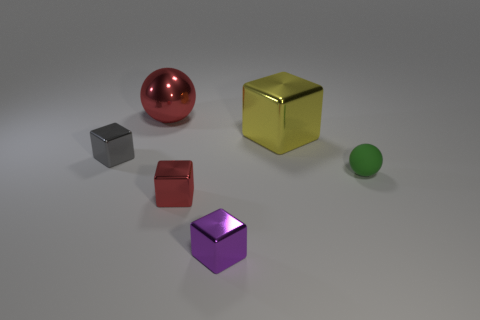Is there anything else that has the same material as the tiny green thing?
Provide a short and direct response. No. How many tiny blocks are behind the small metallic object that is on the left side of the thing that is behind the big yellow cube?
Your answer should be compact. 0. There is a tiny thing that is to the right of the small purple metallic cube; what shape is it?
Keep it short and to the point. Sphere. How many other things are there of the same material as the purple thing?
Ensure brevity in your answer.  4. Do the small rubber sphere and the big metallic block have the same color?
Your response must be concise. No. Is the number of small red metallic objects on the right side of the tiny green rubber thing less than the number of small metallic things to the right of the gray thing?
Ensure brevity in your answer.  Yes. There is a big metallic thing that is the same shape as the tiny gray metal thing; what color is it?
Give a very brief answer. Yellow. Does the red object that is in front of the matte ball have the same size as the green ball?
Your answer should be compact. Yes. Are there fewer green matte objects that are to the right of the green rubber object than blocks?
Provide a short and direct response. Yes. Are there any other things that are the same size as the purple cube?
Offer a very short reply. Yes. 